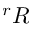<formula> <loc_0><loc_0><loc_500><loc_500>^ { r } R</formula> 